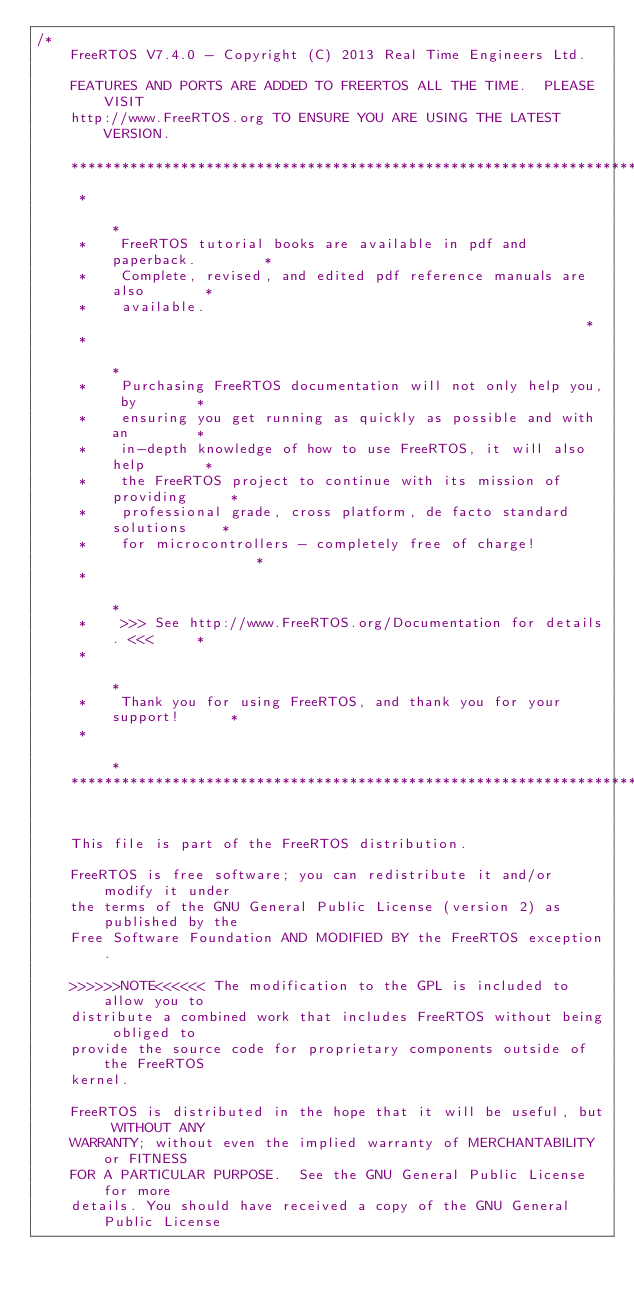<code> <loc_0><loc_0><loc_500><loc_500><_C_>/*
    FreeRTOS V7.4.0 - Copyright (C) 2013 Real Time Engineers Ltd.

    FEATURES AND PORTS ARE ADDED TO FREERTOS ALL THE TIME.  PLEASE VISIT
    http://www.FreeRTOS.org TO ENSURE YOU ARE USING THE LATEST VERSION.

    ***************************************************************************
     *                                                                       *
     *    FreeRTOS tutorial books are available in pdf and paperback.        *
     *    Complete, revised, and edited pdf reference manuals are also       *
     *    available.                                                         *
     *                                                                       *
     *    Purchasing FreeRTOS documentation will not only help you, by       *
     *    ensuring you get running as quickly as possible and with an        *
     *    in-depth knowledge of how to use FreeRTOS, it will also help       *
     *    the FreeRTOS project to continue with its mission of providing     *
     *    professional grade, cross platform, de facto standard solutions    *
     *    for microcontrollers - completely free of charge!                  *
     *                                                                       *
     *    >>> See http://www.FreeRTOS.org/Documentation for details. <<<     *
     *                                                                       *
     *    Thank you for using FreeRTOS, and thank you for your support!      *
     *                                                                       *
    ***************************************************************************


    This file is part of the FreeRTOS distribution.

    FreeRTOS is free software; you can redistribute it and/or modify it under
    the terms of the GNU General Public License (version 2) as published by the
    Free Software Foundation AND MODIFIED BY the FreeRTOS exception.

    >>>>>>NOTE<<<<<< The modification to the GPL is included to allow you to
    distribute a combined work that includes FreeRTOS without being obliged to
    provide the source code for proprietary components outside of the FreeRTOS
    kernel.

    FreeRTOS is distributed in the hope that it will be useful, but WITHOUT ANY
    WARRANTY; without even the implied warranty of MERCHANTABILITY or FITNESS
    FOR A PARTICULAR PURPOSE.  See the GNU General Public License for more
    details. You should have received a copy of the GNU General Public License</code> 